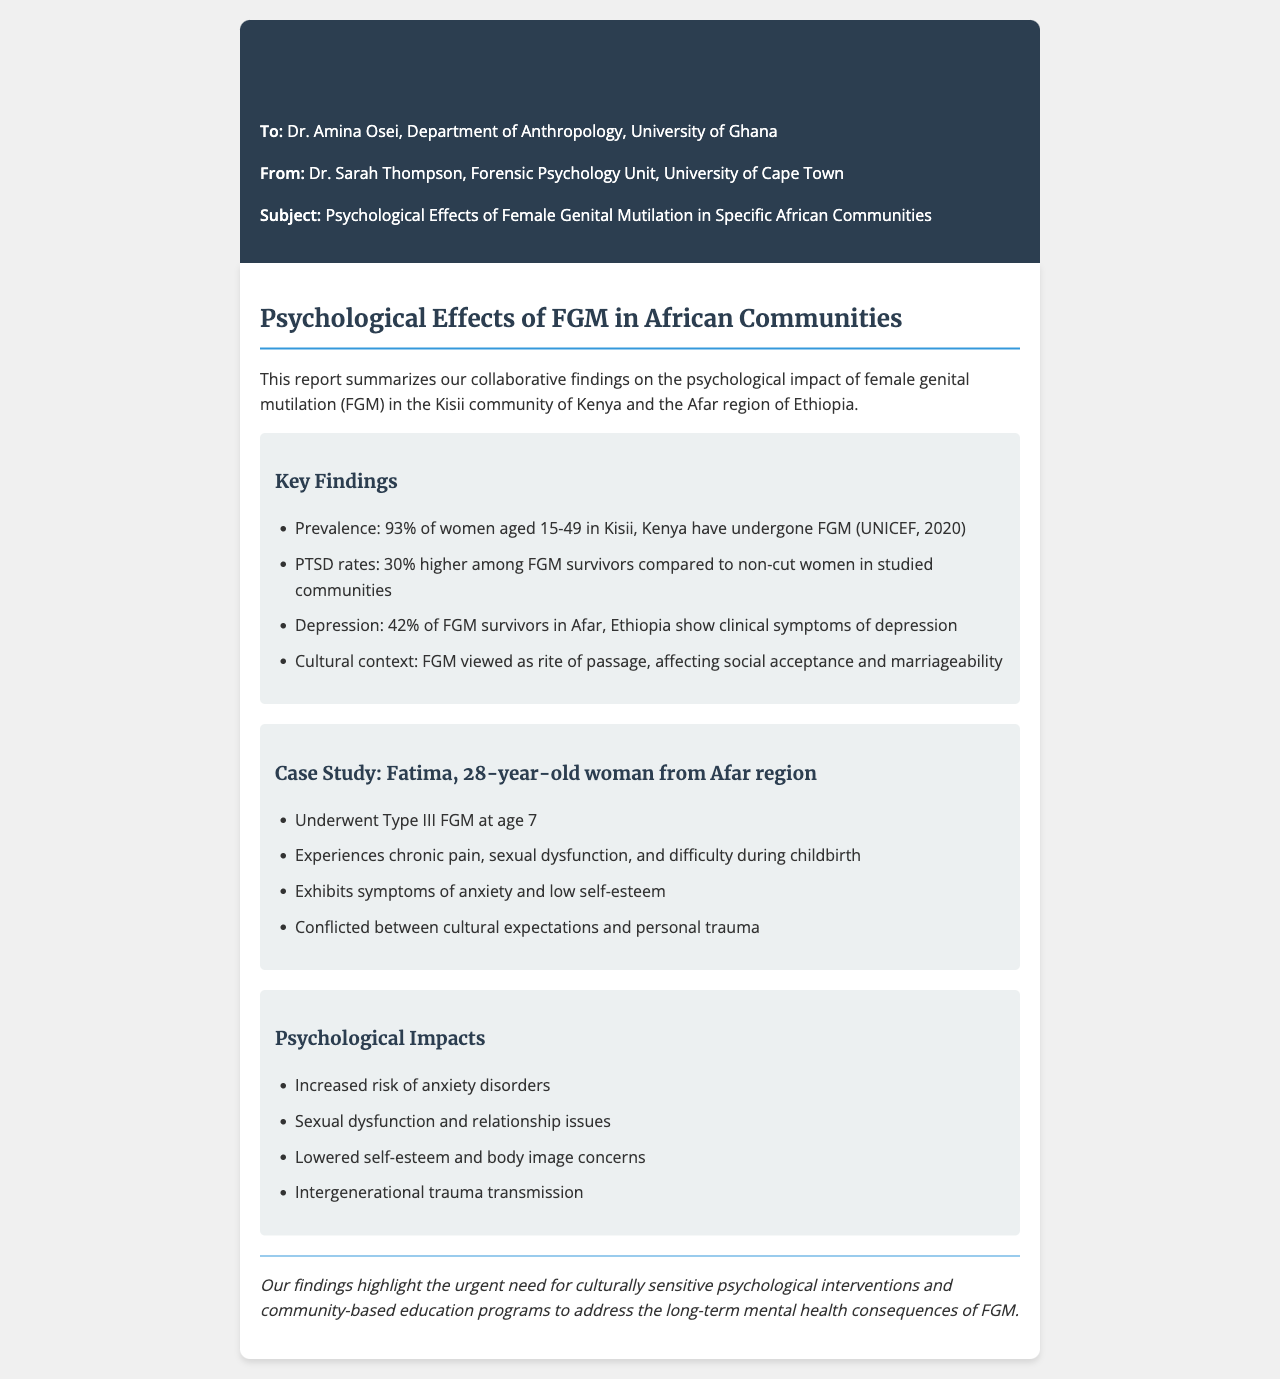What is the prevalence of FGM in Kisii, Kenya? The prevalence is stated as 93% of women aged 15-49 in Kisii, Kenya having undergone FGM.
Answer: 93% What percentage of FGM survivors in Afar, Ethiopia show clinical symptoms of depression? The report indicates that 42% of FGM survivors in Afar, Ethiopia show clinical symptoms of depression.
Answer: 42% How much higher are PTSD rates among FGM survivors compared to non-cut women? The document states that PTSD rates are 30% higher among FGM survivors compared to non-cut women.
Answer: 30% What type of FGM did Fatima undergo? Fatima underwent Type III FGM.
Answer: Type III What age did Fatima undergo FGM? Fatima underwent FGM at the age of 7.
Answer: 7 What is one psychological impact mentioned in the report? The report lists increased risk of anxiety disorders as one of the psychological impacts.
Answer: Increased risk of anxiety disorders What cultural significance does FGM have according to the report? FGM is viewed as a rite of passage, affecting social acceptance and marriageability.
Answer: Rite of passage What is the urgent need highlighted by the findings? The findings highlight the urgent need for culturally sensitive psychological interventions and community-based education programs.
Answer: Culturally sensitive psychological interventions 